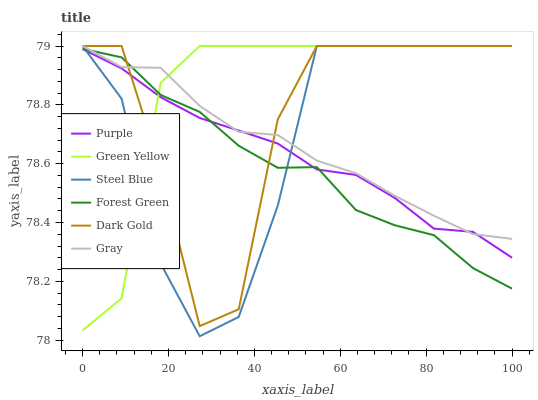Does Forest Green have the minimum area under the curve?
Answer yes or no. Yes. Does Green Yellow have the maximum area under the curve?
Answer yes or no. Yes. Does Dark Gold have the minimum area under the curve?
Answer yes or no. No. Does Dark Gold have the maximum area under the curve?
Answer yes or no. No. Is Purple the smoothest?
Answer yes or no. Yes. Is Dark Gold the roughest?
Answer yes or no. Yes. Is Dark Gold the smoothest?
Answer yes or no. No. Is Purple the roughest?
Answer yes or no. No. Does Steel Blue have the lowest value?
Answer yes or no. Yes. Does Dark Gold have the lowest value?
Answer yes or no. No. Does Green Yellow have the highest value?
Answer yes or no. Yes. Does Purple have the highest value?
Answer yes or no. No. Does Dark Gold intersect Gray?
Answer yes or no. Yes. Is Dark Gold less than Gray?
Answer yes or no. No. Is Dark Gold greater than Gray?
Answer yes or no. No. 